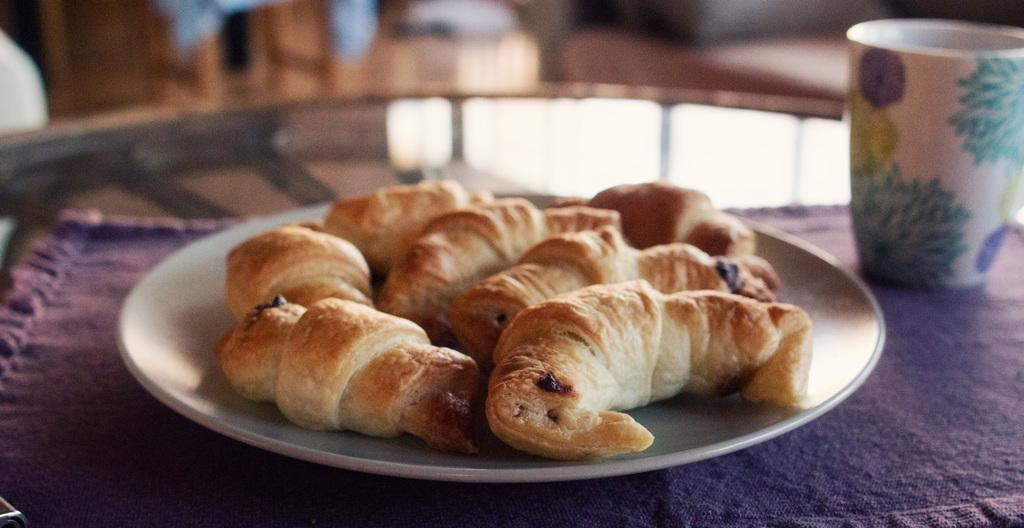What is present on the plate in the image? There is cream-colored food on the plate in the image. What type of container is visible in the image? There is a glass in the image. What color is the cloth in the image? The cloth in the image is purple. Can you describe the food on the plate? The food on the plate is cream-colored. How is the image quality in the background? The image is slightly blurry in the background. What historical event is being commemorated by the fireman in the image? There is no fireman present in the image, and therefore no historical event can be observed. What type of work is being done by the fireman in the image? There is no fireman present in the image, and therefore no work can be observed. 